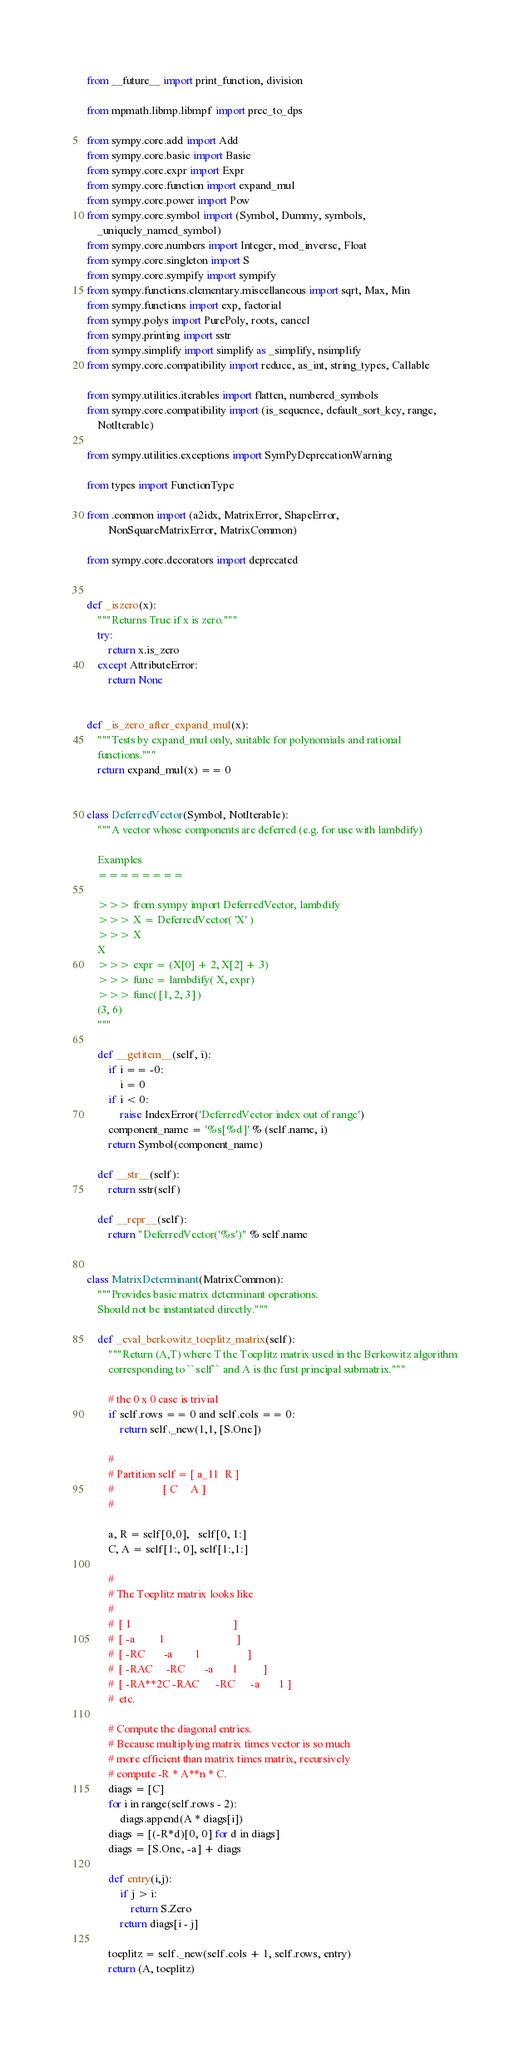<code> <loc_0><loc_0><loc_500><loc_500><_Python_>from __future__ import print_function, division

from mpmath.libmp.libmpf import prec_to_dps

from sympy.core.add import Add
from sympy.core.basic import Basic
from sympy.core.expr import Expr
from sympy.core.function import expand_mul
from sympy.core.power import Pow
from sympy.core.symbol import (Symbol, Dummy, symbols,
    _uniquely_named_symbol)
from sympy.core.numbers import Integer, mod_inverse, Float
from sympy.core.singleton import S
from sympy.core.sympify import sympify
from sympy.functions.elementary.miscellaneous import sqrt, Max, Min
from sympy.functions import exp, factorial
from sympy.polys import PurePoly, roots, cancel
from sympy.printing import sstr
from sympy.simplify import simplify as _simplify, nsimplify
from sympy.core.compatibility import reduce, as_int, string_types, Callable

from sympy.utilities.iterables import flatten, numbered_symbols
from sympy.core.compatibility import (is_sequence, default_sort_key, range,
    NotIterable)

from sympy.utilities.exceptions import SymPyDeprecationWarning

from types import FunctionType

from .common import (a2idx, MatrixError, ShapeError,
        NonSquareMatrixError, MatrixCommon)

from sympy.core.decorators import deprecated


def _iszero(x):
    """Returns True if x is zero."""
    try:
        return x.is_zero
    except AttributeError:
        return None


def _is_zero_after_expand_mul(x):
    """Tests by expand_mul only, suitable for polynomials and rational
    functions."""
    return expand_mul(x) == 0


class DeferredVector(Symbol, NotIterable):
    """A vector whose components are deferred (e.g. for use with lambdify)

    Examples
    ========

    >>> from sympy import DeferredVector, lambdify
    >>> X = DeferredVector( 'X' )
    >>> X
    X
    >>> expr = (X[0] + 2, X[2] + 3)
    >>> func = lambdify( X, expr)
    >>> func( [1, 2, 3] )
    (3, 6)
    """

    def __getitem__(self, i):
        if i == -0:
            i = 0
        if i < 0:
            raise IndexError('DeferredVector index out of range')
        component_name = '%s[%d]' % (self.name, i)
        return Symbol(component_name)

    def __str__(self):
        return sstr(self)

    def __repr__(self):
        return "DeferredVector('%s')" % self.name


class MatrixDeterminant(MatrixCommon):
    """Provides basic matrix determinant operations.
    Should not be instantiated directly."""

    def _eval_berkowitz_toeplitz_matrix(self):
        """Return (A,T) where T the Toeplitz matrix used in the Berkowitz algorithm
        corresponding to ``self`` and A is the first principal submatrix."""

        # the 0 x 0 case is trivial
        if self.rows == 0 and self.cols == 0:
            return self._new(1,1, [S.One])

        #
        # Partition self = [ a_11  R ]
        #                  [ C     A ]
        #

        a, R = self[0,0],   self[0, 1:]
        C, A = self[1:, 0], self[1:,1:]

        #
        # The Toeplitz matrix looks like
        #
        #  [ 1                                     ]
        #  [ -a         1                          ]
        #  [ -RC       -a        1                 ]
        #  [ -RAC     -RC       -a       1         ]
        #  [ -RA**2C -RAC      -RC      -a       1 ]
        #  etc.

        # Compute the diagonal entries.
        # Because multiplying matrix times vector is so much
        # more efficient than matrix times matrix, recursively
        # compute -R * A**n * C.
        diags = [C]
        for i in range(self.rows - 2):
            diags.append(A * diags[i])
        diags = [(-R*d)[0, 0] for d in diags]
        diags = [S.One, -a] + diags

        def entry(i,j):
            if j > i:
                return S.Zero
            return diags[i - j]

        toeplitz = self._new(self.cols + 1, self.rows, entry)
        return (A, toeplitz)
</code> 